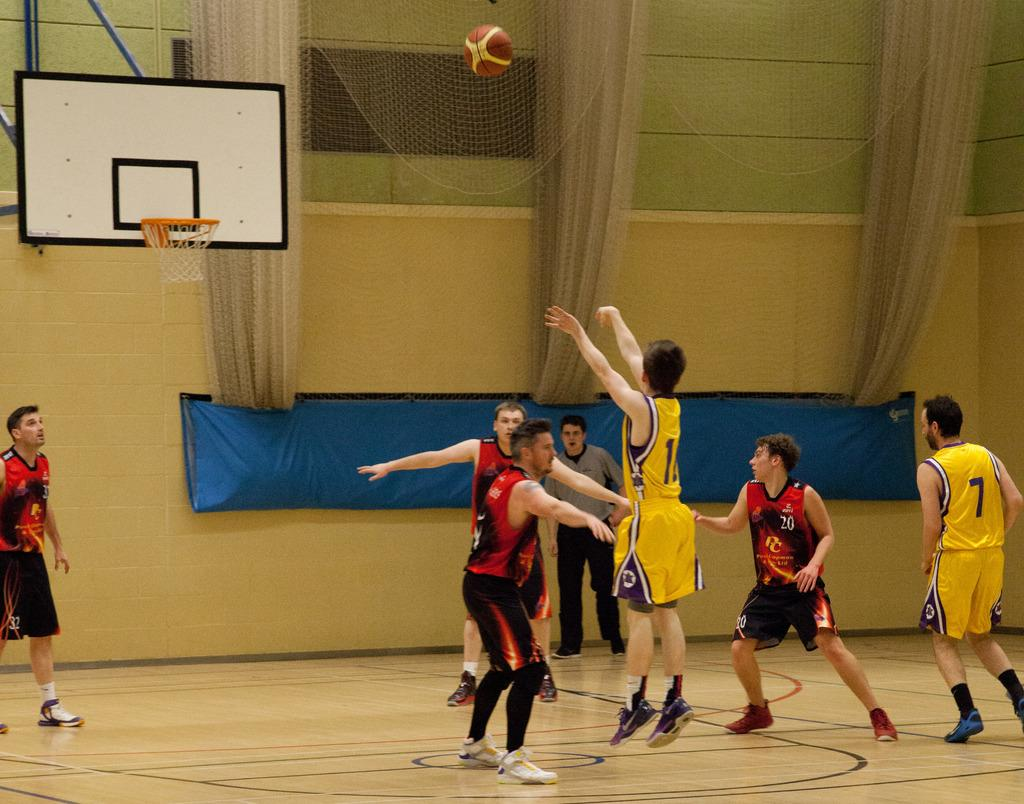<image>
Present a compact description of the photo's key features. People play basketball, one has the number 7 on a yellow shirt 